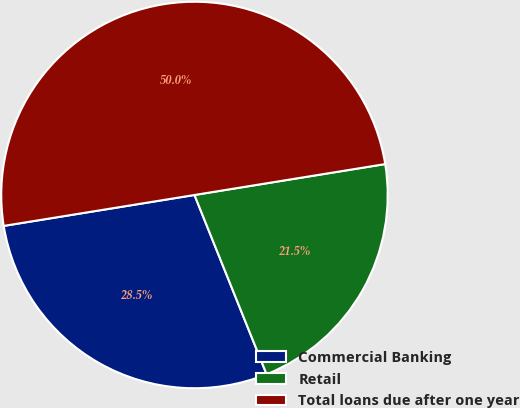Convert chart. <chart><loc_0><loc_0><loc_500><loc_500><pie_chart><fcel>Commercial Banking<fcel>Retail<fcel>Total loans due after one year<nl><fcel>28.53%<fcel>21.47%<fcel>50.0%<nl></chart> 